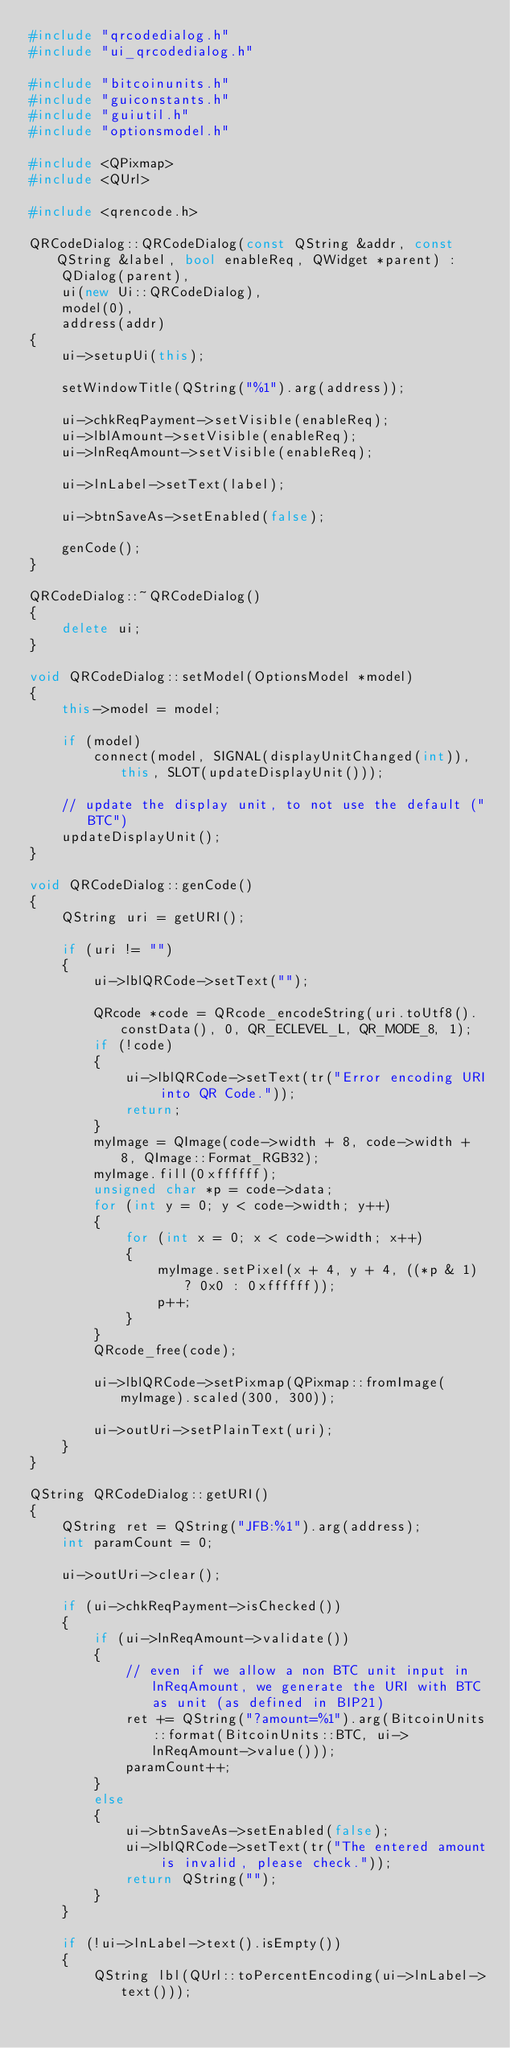<code> <loc_0><loc_0><loc_500><loc_500><_C++_>#include "qrcodedialog.h"
#include "ui_qrcodedialog.h"

#include "bitcoinunits.h"
#include "guiconstants.h"
#include "guiutil.h"
#include "optionsmodel.h"

#include <QPixmap>
#include <QUrl>

#include <qrencode.h>

QRCodeDialog::QRCodeDialog(const QString &addr, const QString &label, bool enableReq, QWidget *parent) :
    QDialog(parent),
    ui(new Ui::QRCodeDialog),
    model(0),
    address(addr)
{
    ui->setupUi(this);

    setWindowTitle(QString("%1").arg(address));

    ui->chkReqPayment->setVisible(enableReq);
    ui->lblAmount->setVisible(enableReq);
    ui->lnReqAmount->setVisible(enableReq);

    ui->lnLabel->setText(label);

    ui->btnSaveAs->setEnabled(false);

    genCode();
}

QRCodeDialog::~QRCodeDialog()
{
    delete ui;
}

void QRCodeDialog::setModel(OptionsModel *model)
{
    this->model = model;

    if (model)
        connect(model, SIGNAL(displayUnitChanged(int)), this, SLOT(updateDisplayUnit()));

    // update the display unit, to not use the default ("BTC")
    updateDisplayUnit();
}

void QRCodeDialog::genCode()
{
    QString uri = getURI();

    if (uri != "")
    {
        ui->lblQRCode->setText("");

        QRcode *code = QRcode_encodeString(uri.toUtf8().constData(), 0, QR_ECLEVEL_L, QR_MODE_8, 1);
        if (!code)
        {
            ui->lblQRCode->setText(tr("Error encoding URI into QR Code."));
            return;
        }
        myImage = QImage(code->width + 8, code->width + 8, QImage::Format_RGB32);
        myImage.fill(0xffffff);
        unsigned char *p = code->data;
        for (int y = 0; y < code->width; y++)
        {
            for (int x = 0; x < code->width; x++)
            {
                myImage.setPixel(x + 4, y + 4, ((*p & 1) ? 0x0 : 0xffffff));
                p++;
            }
        }
        QRcode_free(code);

        ui->lblQRCode->setPixmap(QPixmap::fromImage(myImage).scaled(300, 300));

        ui->outUri->setPlainText(uri);
    }
}

QString QRCodeDialog::getURI()
{
    QString ret = QString("JFB:%1").arg(address);
    int paramCount = 0;

    ui->outUri->clear();

    if (ui->chkReqPayment->isChecked())
    {
        if (ui->lnReqAmount->validate())
        {
            // even if we allow a non BTC unit input in lnReqAmount, we generate the URI with BTC as unit (as defined in BIP21)
            ret += QString("?amount=%1").arg(BitcoinUnits::format(BitcoinUnits::BTC, ui->lnReqAmount->value()));
            paramCount++;
        }
        else
        {
            ui->btnSaveAs->setEnabled(false);
            ui->lblQRCode->setText(tr("The entered amount is invalid, please check."));
            return QString("");
        }
    }

    if (!ui->lnLabel->text().isEmpty())
    {
        QString lbl(QUrl::toPercentEncoding(ui->lnLabel->text()));</code> 